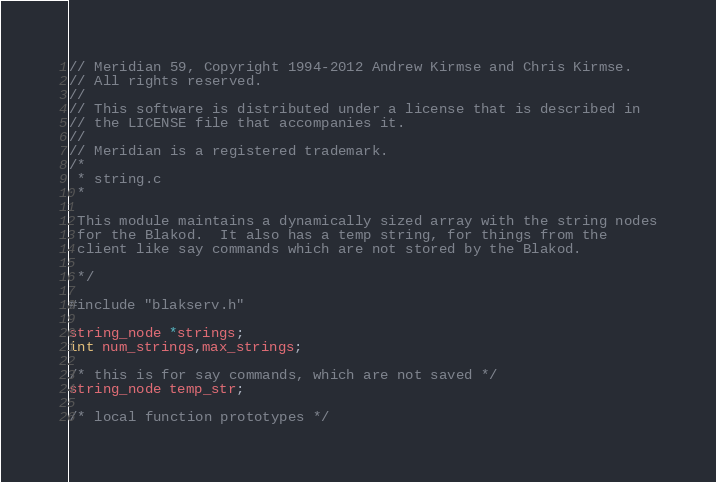Convert code to text. <code><loc_0><loc_0><loc_500><loc_500><_C_>// Meridian 59, Copyright 1994-2012 Andrew Kirmse and Chris Kirmse.
// All rights reserved.
//
// This software is distributed under a license that is described in
// the LICENSE file that accompanies it.
//
// Meridian is a registered trademark.
/*
 * string.c
 *

 This module maintains a dynamically sized array with the string nodes
 for the Blakod.  It also has a temp string, for things from the
 client like say commands which are not stored by the Blakod.

 */

#include "blakserv.h"

string_node *strings;
int num_strings,max_strings;

/* this is for say commands, which are not saved */
string_node temp_str;

/* local function prototypes */</code> 